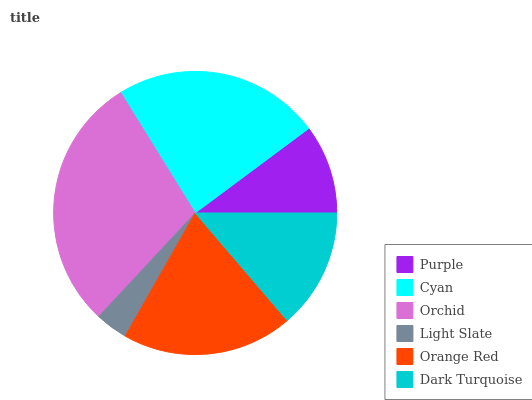Is Light Slate the minimum?
Answer yes or no. Yes. Is Orchid the maximum?
Answer yes or no. Yes. Is Cyan the minimum?
Answer yes or no. No. Is Cyan the maximum?
Answer yes or no. No. Is Cyan greater than Purple?
Answer yes or no. Yes. Is Purple less than Cyan?
Answer yes or no. Yes. Is Purple greater than Cyan?
Answer yes or no. No. Is Cyan less than Purple?
Answer yes or no. No. Is Orange Red the high median?
Answer yes or no. Yes. Is Dark Turquoise the low median?
Answer yes or no. Yes. Is Orchid the high median?
Answer yes or no. No. Is Cyan the low median?
Answer yes or no. No. 